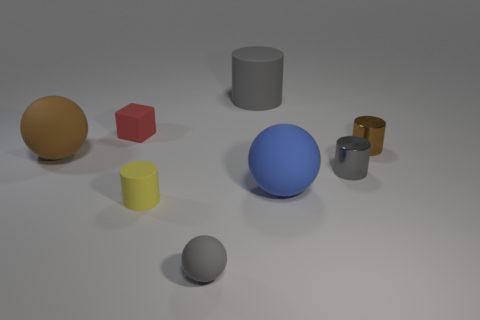Can you tell me the number of geometric shapes present? There are seven geometric shapes visible: a yellow sphere, a red cube, a blue sphere, a grey cylinder, a silver sphere, a yellow cylinder, and a golden ring. Which shapes have shadows? Each object in the image has a shadow due to the light source above them. 